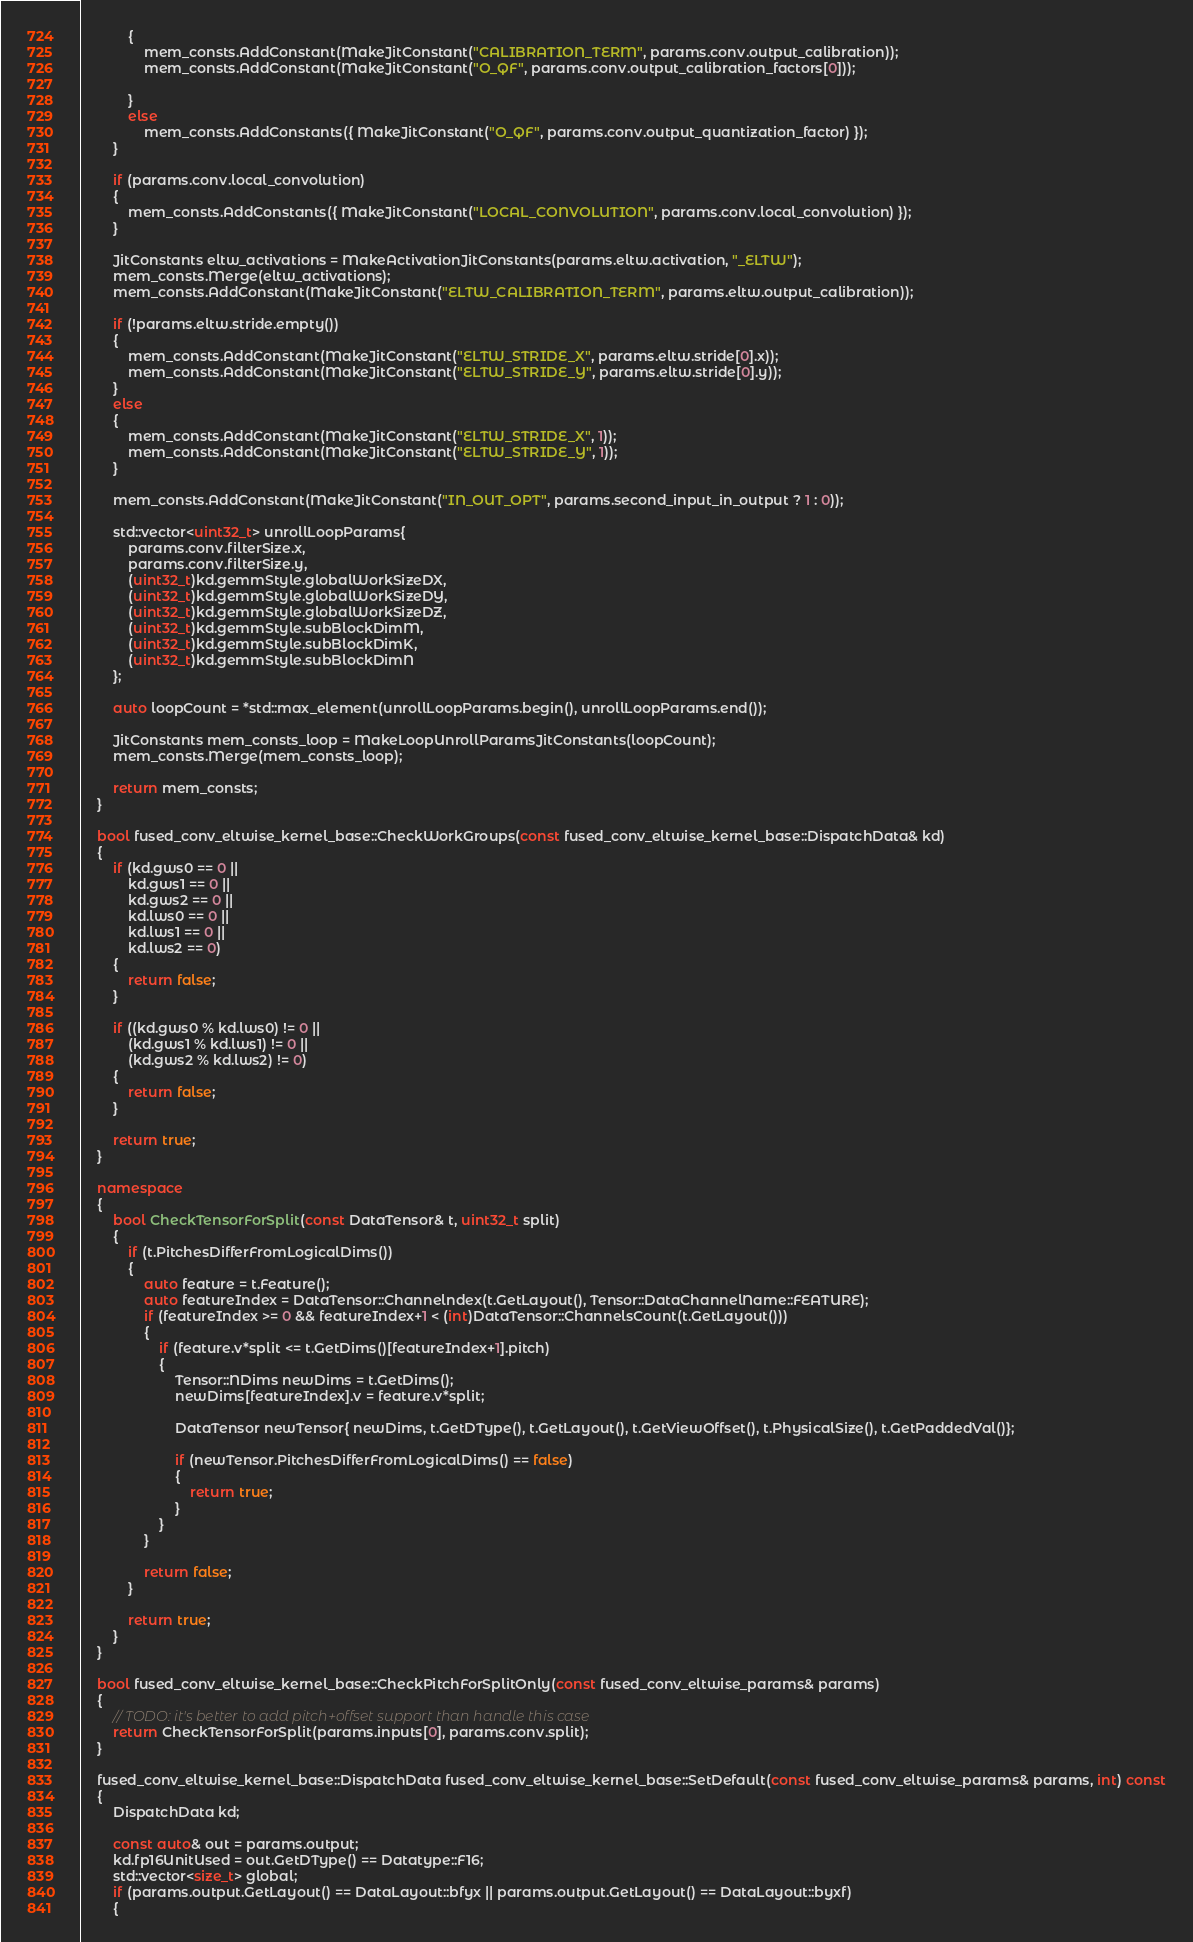Convert code to text. <code><loc_0><loc_0><loc_500><loc_500><_C++_>            {
                mem_consts.AddConstant(MakeJitConstant("CALIBRATION_TERM", params.conv.output_calibration));
                mem_consts.AddConstant(MakeJitConstant("O_QF", params.conv.output_calibration_factors[0]));

            }
            else
                mem_consts.AddConstants({ MakeJitConstant("O_QF", params.conv.output_quantization_factor) });
        }

        if (params.conv.local_convolution)
        {
            mem_consts.AddConstants({ MakeJitConstant("LOCAL_CONVOLUTION", params.conv.local_convolution) });
        }

        JitConstants eltw_activations = MakeActivationJitConstants(params.eltw.activation, "_ELTW");
        mem_consts.Merge(eltw_activations);
        mem_consts.AddConstant(MakeJitConstant("ELTW_CALIBRATION_TERM", params.eltw.output_calibration));

        if (!params.eltw.stride.empty())
        {
            mem_consts.AddConstant(MakeJitConstant("ELTW_STRIDE_X", params.eltw.stride[0].x));
            mem_consts.AddConstant(MakeJitConstant("ELTW_STRIDE_Y", params.eltw.stride[0].y));
        }
        else
        {
            mem_consts.AddConstant(MakeJitConstant("ELTW_STRIDE_X", 1));
            mem_consts.AddConstant(MakeJitConstant("ELTW_STRIDE_Y", 1));
        }

        mem_consts.AddConstant(MakeJitConstant("IN_OUT_OPT", params.second_input_in_output ? 1 : 0));

        std::vector<uint32_t> unrollLoopParams{
            params.conv.filterSize.x,
            params.conv.filterSize.y,
            (uint32_t)kd.gemmStyle.globalWorkSizeDX,
            (uint32_t)kd.gemmStyle.globalWorkSizeDY,
            (uint32_t)kd.gemmStyle.globalWorkSizeDZ,
            (uint32_t)kd.gemmStyle.subBlockDimM,
            (uint32_t)kd.gemmStyle.subBlockDimK,
            (uint32_t)kd.gemmStyle.subBlockDimN
        };

        auto loopCount = *std::max_element(unrollLoopParams.begin(), unrollLoopParams.end());

        JitConstants mem_consts_loop = MakeLoopUnrollParamsJitConstants(loopCount);
        mem_consts.Merge(mem_consts_loop);

        return mem_consts;
    }

    bool fused_conv_eltwise_kernel_base::CheckWorkGroups(const fused_conv_eltwise_kernel_base::DispatchData& kd)
    {
        if (kd.gws0 == 0 ||
            kd.gws1 == 0 ||
            kd.gws2 == 0 ||
            kd.lws0 == 0 ||
            kd.lws1 == 0 ||
            kd.lws2 == 0)
        {
            return false;
        }

        if ((kd.gws0 % kd.lws0) != 0 ||
            (kd.gws1 % kd.lws1) != 0 ||
            (kd.gws2 % kd.lws2) != 0)
        {
            return false;
        }

        return true;
    }

    namespace
    {
        bool CheckTensorForSplit(const DataTensor& t, uint32_t split)
        {
            if (t.PitchesDifferFromLogicalDims())
            {
                auto feature = t.Feature();
                auto featureIndex = DataTensor::Channelndex(t.GetLayout(), Tensor::DataChannelName::FEATURE);
                if (featureIndex >= 0 && featureIndex+1 < (int)DataTensor::ChannelsCount(t.GetLayout()))
                {
                    if (feature.v*split <= t.GetDims()[featureIndex+1].pitch)
                    {
                        Tensor::NDims newDims = t.GetDims();
                        newDims[featureIndex].v = feature.v*split;
                        
                        DataTensor newTensor{ newDims, t.GetDType(), t.GetLayout(), t.GetViewOffset(), t.PhysicalSize(), t.GetPaddedVal()};

                        if (newTensor.PitchesDifferFromLogicalDims() == false)
                        {
                            return true;
                        }
                    }
                }

                return false;
            }

            return true;
        }
    }

    bool fused_conv_eltwise_kernel_base::CheckPitchForSplitOnly(const fused_conv_eltwise_params& params)
    {
        // TODO: it's better to add pitch+offset support than handle this case
        return CheckTensorForSplit(params.inputs[0], params.conv.split);
    }

    fused_conv_eltwise_kernel_base::DispatchData fused_conv_eltwise_kernel_base::SetDefault(const fused_conv_eltwise_params& params, int) const
    {
        DispatchData kd;

        const auto& out = params.output;
        kd.fp16UnitUsed = out.GetDType() == Datatype::F16;
        std::vector<size_t> global;
        if (params.output.GetLayout() == DataLayout::bfyx || params.output.GetLayout() == DataLayout::byxf)
        {</code> 